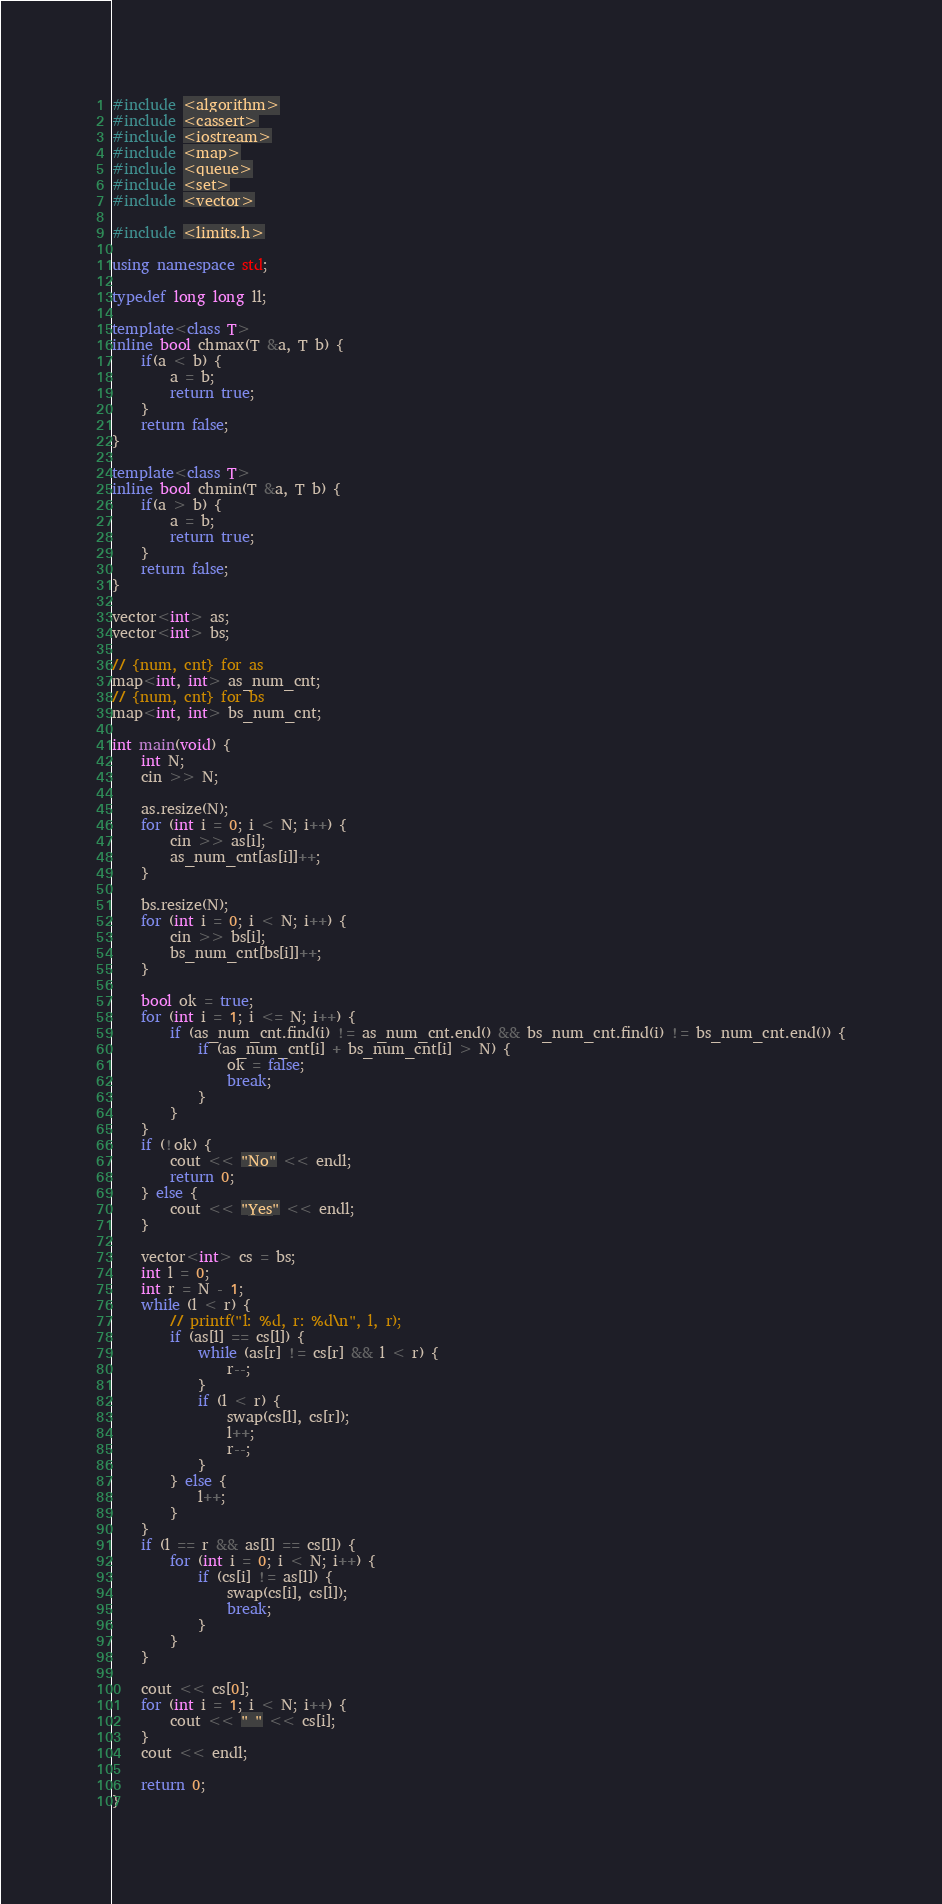Convert code to text. <code><loc_0><loc_0><loc_500><loc_500><_C++_>#include <algorithm>
#include <cassert>
#include <iostream>
#include <map>
#include <queue>
#include <set>
#include <vector>

#include <limits.h>

using namespace std;

typedef long long ll;

template<class T>
inline bool chmax(T &a, T b) {
    if(a < b) {
        a = b;
        return true;
    }
    return false;
}

template<class T>
inline bool chmin(T &a, T b) {
    if(a > b) {
        a = b;
        return true;
    }
    return false;
}

vector<int> as;
vector<int> bs;

// {num, cnt} for as
map<int, int> as_num_cnt;
// {num, cnt} for bs
map<int, int> bs_num_cnt;

int main(void) {
    int N;
    cin >> N;

    as.resize(N);
    for (int i = 0; i < N; i++) {
        cin >> as[i];
        as_num_cnt[as[i]]++;
    }

    bs.resize(N);
    for (int i = 0; i < N; i++) {
        cin >> bs[i];
        bs_num_cnt[bs[i]]++;
    }

    bool ok = true;
    for (int i = 1; i <= N; i++) {
        if (as_num_cnt.find(i) != as_num_cnt.end() && bs_num_cnt.find(i) != bs_num_cnt.end()) {
            if (as_num_cnt[i] + bs_num_cnt[i] > N) {
                ok = false;
                break;
            }
        }
    }
    if (!ok) {
        cout << "No" << endl;
        return 0;
    } else {
        cout << "Yes" << endl;
    }

    vector<int> cs = bs;
    int l = 0;
    int r = N - 1;
    while (l < r) {
        // printf("l: %d, r: %d\n", l, r);
        if (as[l] == cs[l]) {
            while (as[r] != cs[r] && l < r) {
                r--;
            }
            if (l < r) {
                swap(cs[l], cs[r]);
                l++;
                r--;
            }
        } else {
            l++;
        }
    }
    if (l == r && as[l] == cs[l]) {
        for (int i = 0; i < N; i++) {
            if (cs[i] != as[l]) {
                swap(cs[i], cs[l]);
                break;
            }
        }
    }

    cout << cs[0];
    for (int i = 1; i < N; i++) {
        cout << " " << cs[i];
    }
    cout << endl;

    return 0;
}
</code> 